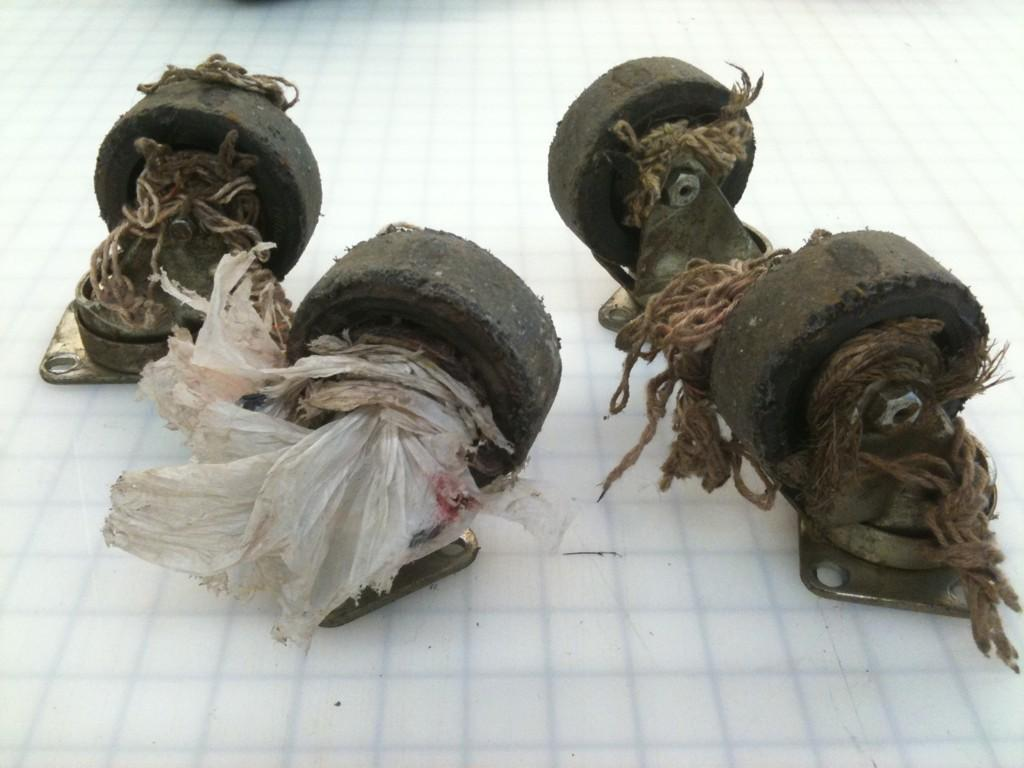What can be seen in the image? In the image, there are objects placed on a surface. Can you describe the objects on the surface? Unfortunately, the facts provided do not specify the nature of the objects on the surface. What type of surface are the objects placed on? The facts provided do not specify the type of surface the objects are placed on. What crime is being committed in the image? There is no crime being committed in the image, as the facts provided do not mention any criminal activity. What statement is being made by the objects in the image? There is no statement being made by the objects in the image, as the facts provided do not mention any specific message or meaning associated with the objects. 